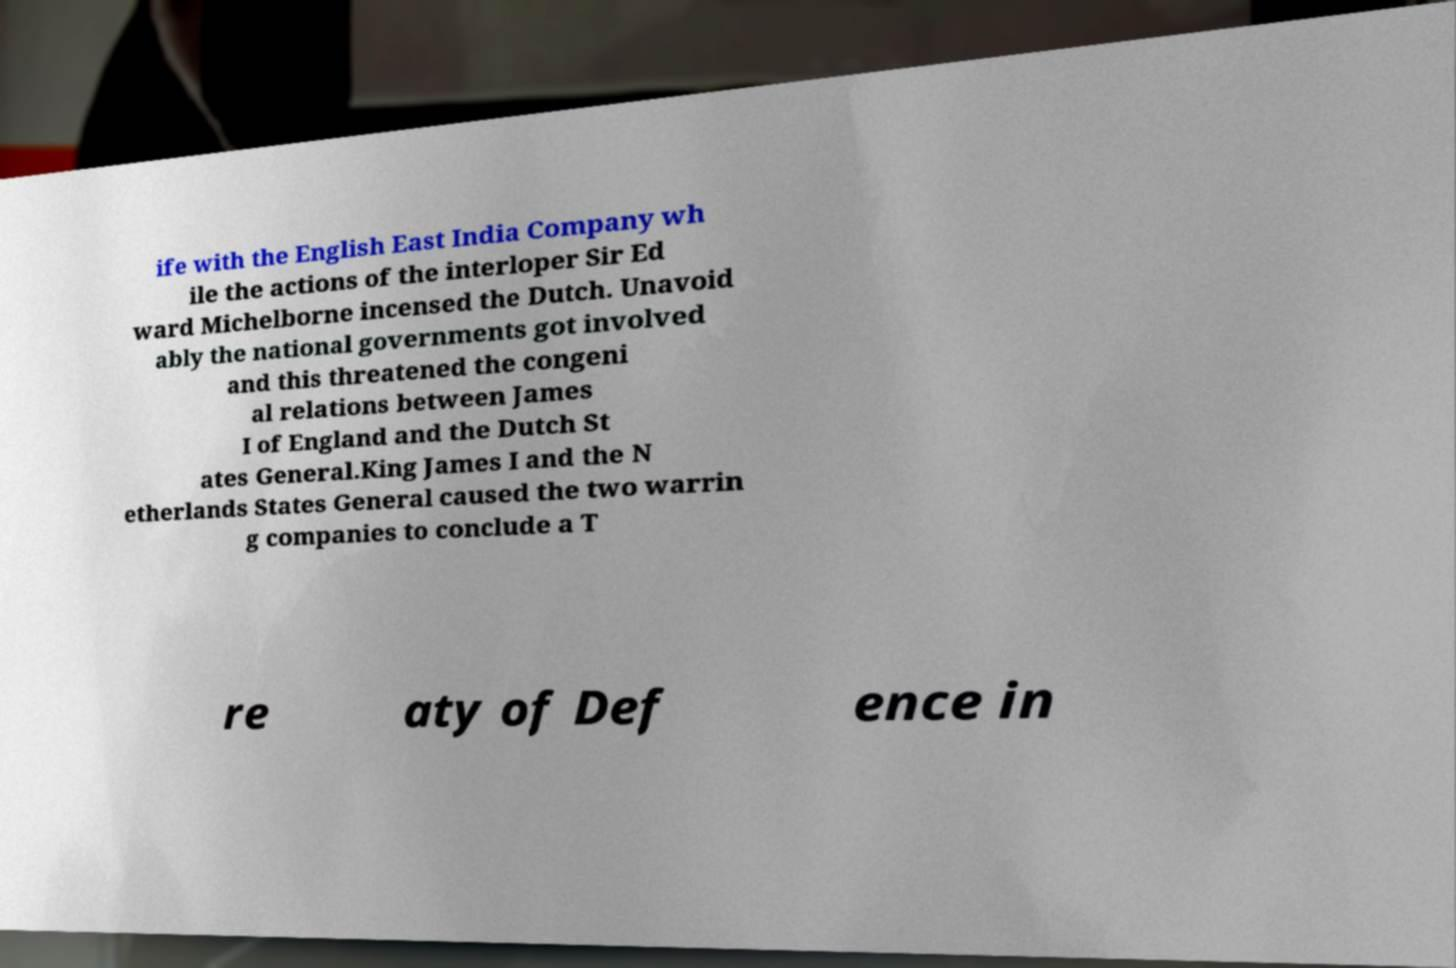Please read and relay the text visible in this image. What does it say? ife with the English East India Company wh ile the actions of the interloper Sir Ed ward Michelborne incensed the Dutch. Unavoid ably the national governments got involved and this threatened the congeni al relations between James I of England and the Dutch St ates General.King James I and the N etherlands States General caused the two warrin g companies to conclude a T re aty of Def ence in 